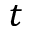<formula> <loc_0><loc_0><loc_500><loc_500>t</formula> 